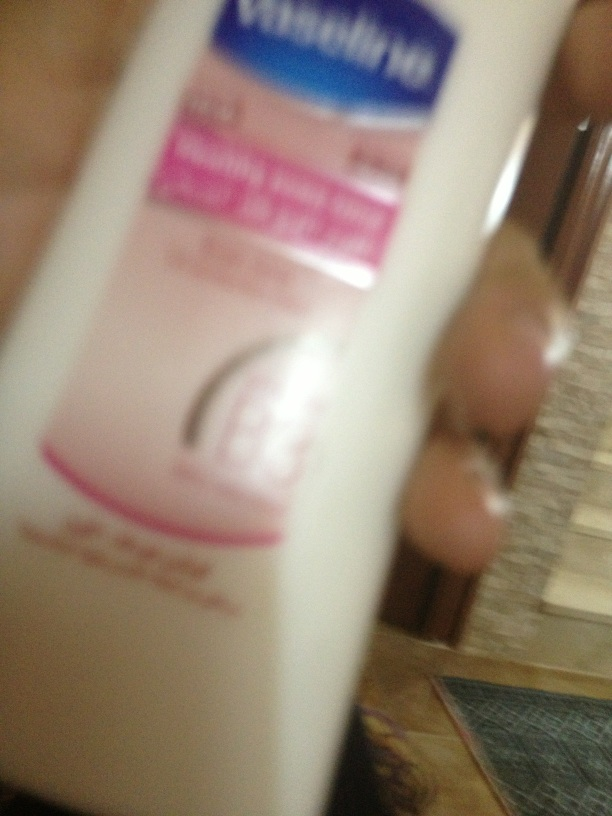Describe the most likely use of this product. The most likely use of this Vaseline lotion is as a daily moisturizer for dry skin. It helps to keep the skin hydrated, soft, and smooth. It's commonly used after showers, before bed, or whenever the skin feels dry and in need of moisture. Can you elaborate on its specific ingredients and how they benefit the skin? Certainly! Vaseline lotions often contain ingredients like petroleum jelly, glycerin, and aloe vera. Petroleum jelly creates a protective barrier on the skin to lock in moisture. Glycerin is a powerful humectant that draws moisture into the skin, while aloe vera soothes and calms irritated skin. Together, these ingredients work to provide long-lasting hydration and protection for your skin. What is a unique way someone might use this lotion? A unique use for Vaseline lotion could be as a protective barrier on your hands before gardening. By applying a layer to your hands, you can prevent dirt from embedding into your skin and make cleanup easier afterward. Plus, it will keep your hands moisturized while you work! 